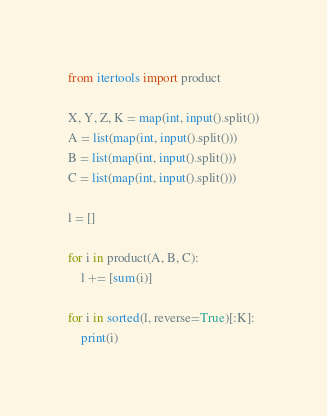<code> <loc_0><loc_0><loc_500><loc_500><_Python_>from itertools import product

X, Y, Z, K = map(int, input().split())
A = list(map(int, input().split()))
B = list(map(int, input().split()))
C = list(map(int, input().split()))

l = []

for i in product(A, B, C):
    l += [sum(i)]

for i in sorted(l, reverse=True)[:K]:
    print(i)</code> 